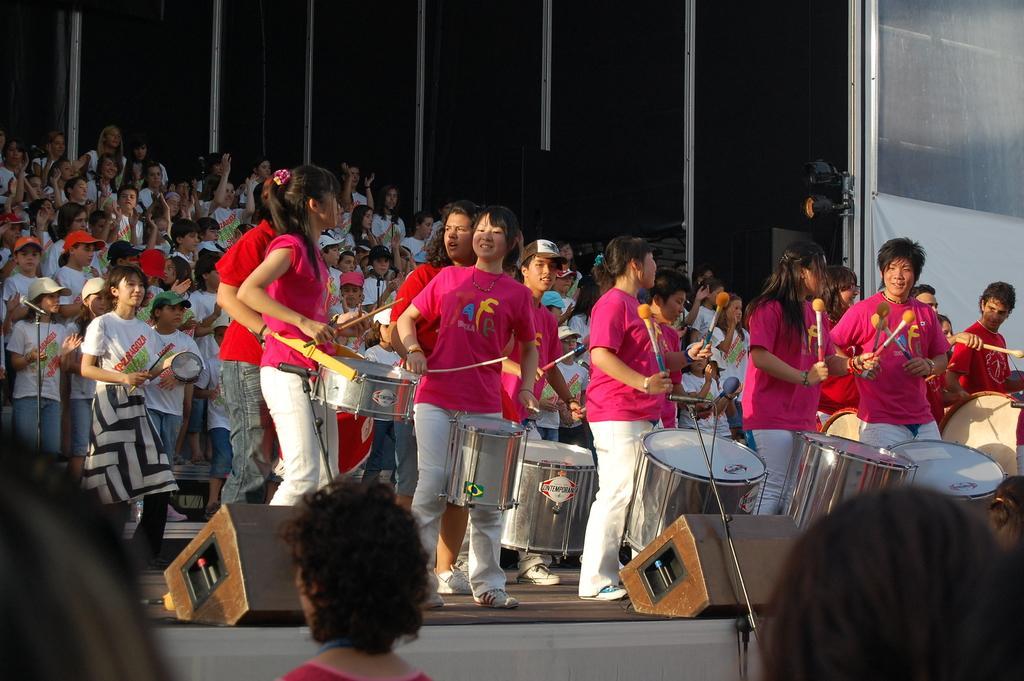In one or two sentences, can you explain what this image depicts? In this image I can see a group of people who are playing musical instruments on the stage. 